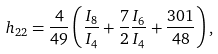<formula> <loc_0><loc_0><loc_500><loc_500>h _ { 2 2 } = \frac { 4 } { 4 9 } \left ( \frac { I _ { 8 } } { I _ { 4 } } + \frac { 7 } { 2 } \frac { I _ { 6 } } { I _ { 4 } } + \frac { 3 0 1 } { 4 8 } \right ) ,</formula> 